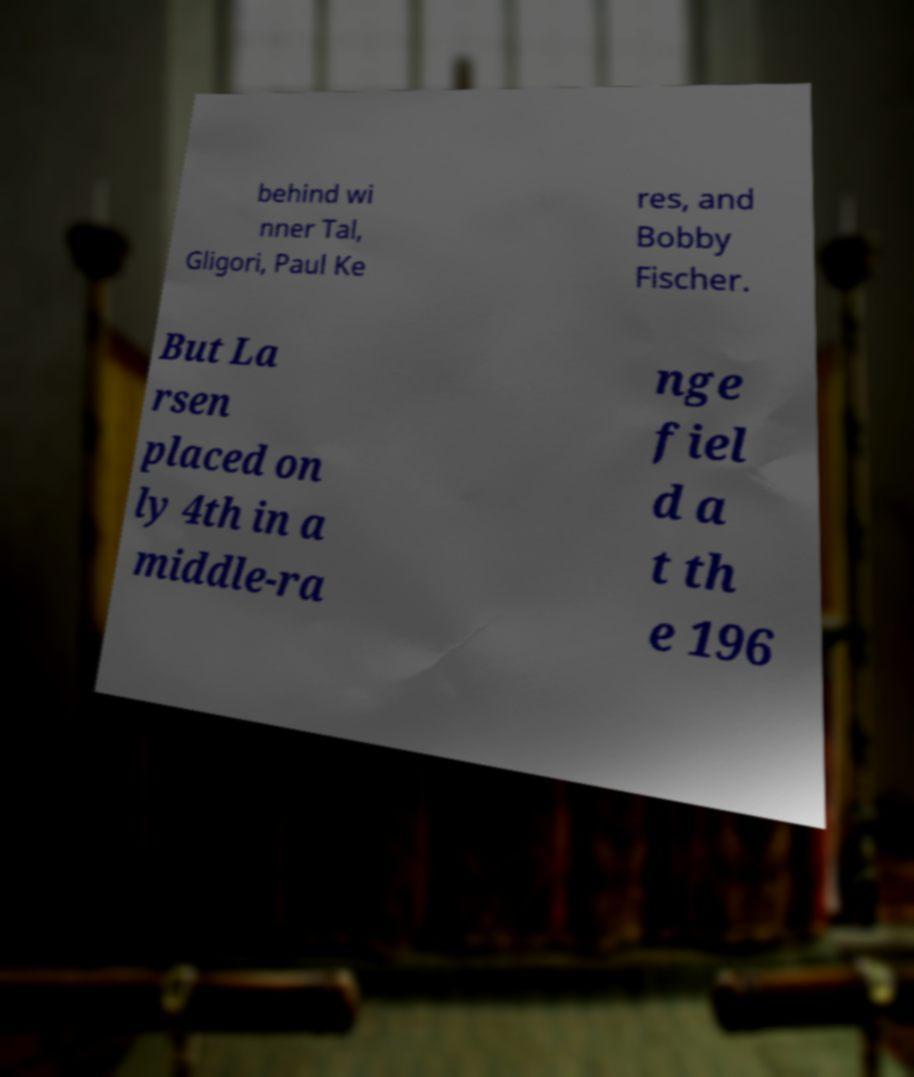Please read and relay the text visible in this image. What does it say? behind wi nner Tal, Gligori, Paul Ke res, and Bobby Fischer. But La rsen placed on ly 4th in a middle-ra nge fiel d a t th e 196 